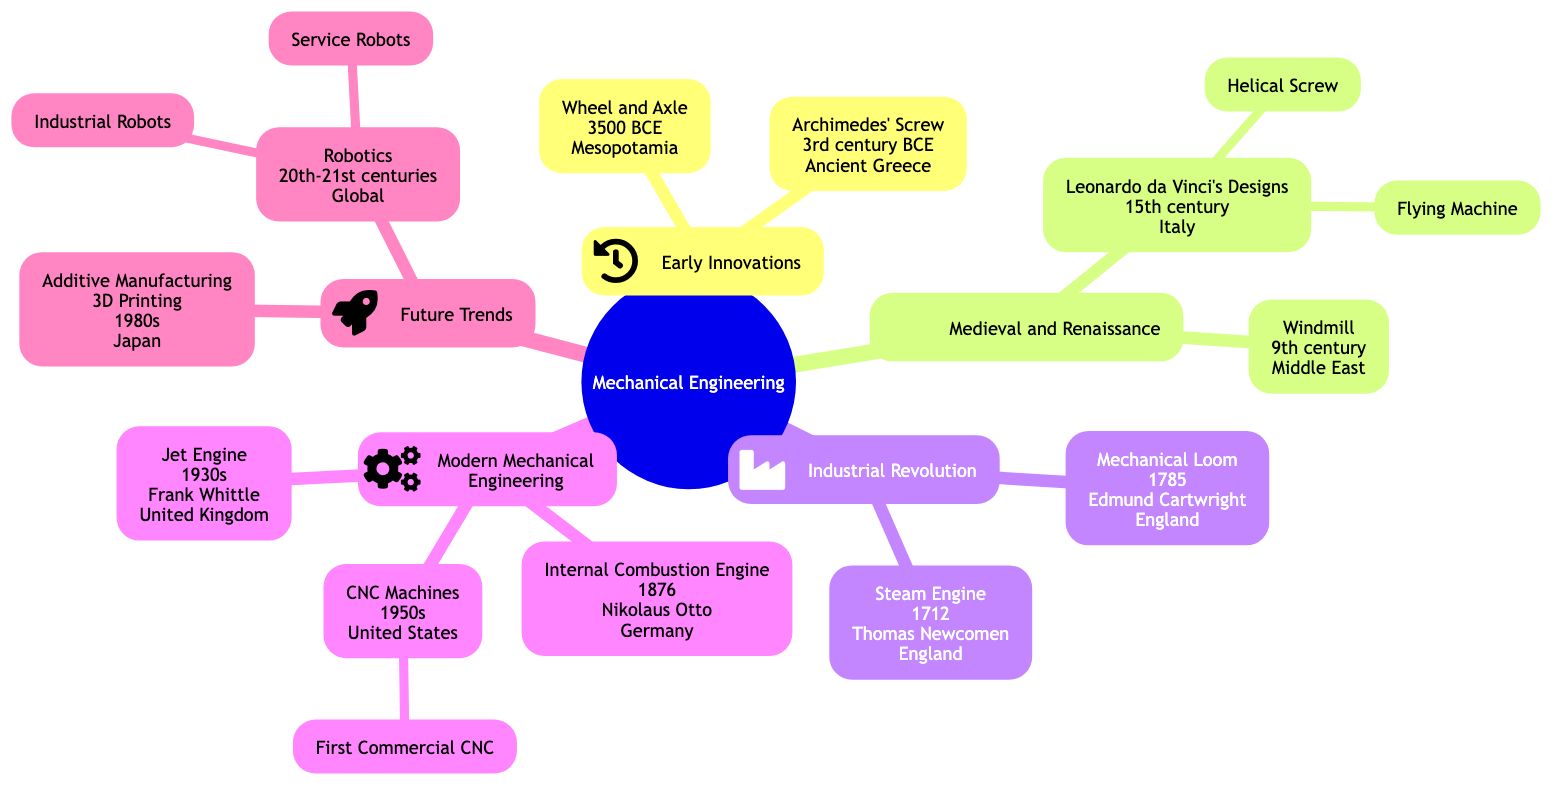What is the earliest invention in mechanical engineering? The diagram indicates that the earliest invention is the "Wheel and Axle," which dates back to 3500 BCE in Mesopotamia.
Answer: Wheel and Axle Which invention is attributed to Thomas Newcomen? According to the diagram, the invention attributed to Thomas Newcomen is the "Steam Engine," developed in 1712 in England.
Answer: Steam Engine How many subbranches are under "Modern Mechanical Engineering"? The "Modern Mechanical Engineering" branch has three subbranches: Internal Combustion Engine, Jet Engine, and CNC Machines. Therefore, the count is three.
Answer: 3 Which region is associated with Additive Manufacturing? The diagram shows that Additive Manufacturing, or 3D Printing, is associated with Japan, where it originated during the 1980s.
Answer: Japan What were Leonardo da Vinci's contributions in the 15th century? The contributions credited to Leonardo da Vinci in the 15th century include "Flying Machine" and "Helical Screw," as shown in the diagram.
Answer: Flying Machine, Helical Screw What is the relationship between "CNC Machines" and "First Commercial CNC"? “First Commercial CNC” is a subbranch of “CNC Machines,” indicating that it is a specific type or instance within the broader context of CNC Machines in the diagram.
Answer: Subbranch Which invention from the Industrial Revolution was created in 1785? The diagram indicates that the "Mechanical Loom" was created in the year 1785 during the Industrial Revolution in England.
Answer: Mechanical Loom What is the latest trend mentioned in the family tree? The latest trend mentioned in the diagram under "Future Trends" is "Robotics," which spans the 20th to 21st centuries globally.
Answer: Robotics Which invention is known as a precursor to modern engines? The diagram indicates that the "Internal Combustion Engine," developed by Nikolaus Otto in 1876, is a precursor to many modern engines.
Answer: Internal Combustion Engine 